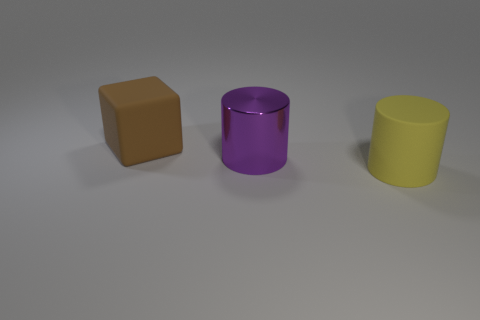Is the size of the brown cube that is behind the purple metallic object the same as the cylinder in front of the large metal object?
Make the answer very short. Yes. What number of objects are either small rubber cubes or cylinders?
Your response must be concise. 2. There is a matte object that is in front of the big brown cube; what is its size?
Your answer should be compact. Large. There is a rubber thing right of the object behind the large metal thing; what number of large yellow things are behind it?
Provide a succinct answer. 0. Does the rubber cylinder have the same color as the big metal cylinder?
Make the answer very short. No. How many big rubber things are both to the left of the large shiny object and to the right of the big brown matte thing?
Keep it short and to the point. 0. There is a thing left of the shiny object; what is its shape?
Make the answer very short. Cube. Are there fewer rubber objects that are on the right side of the large brown block than big objects in front of the large purple metallic cylinder?
Your response must be concise. No. Does the object that is in front of the large purple object have the same material as the object that is behind the big purple metallic cylinder?
Provide a succinct answer. Yes. The big brown object is what shape?
Ensure brevity in your answer.  Cube. 